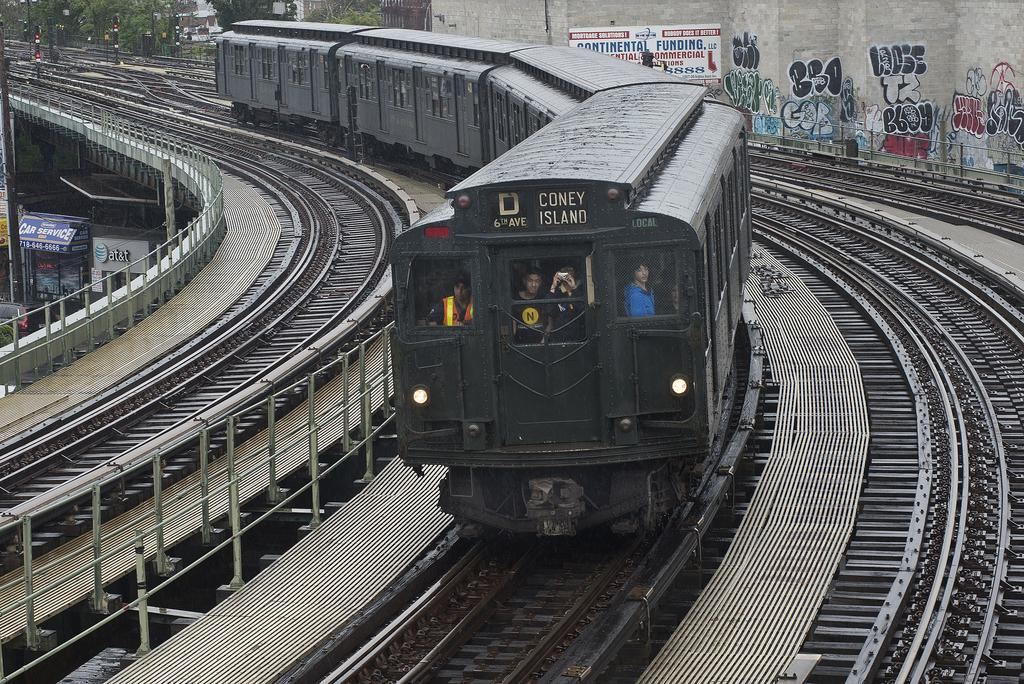Provide a one-sentence caption for the provided image. The D train comes around a bend in the middle of multiple tracks. 